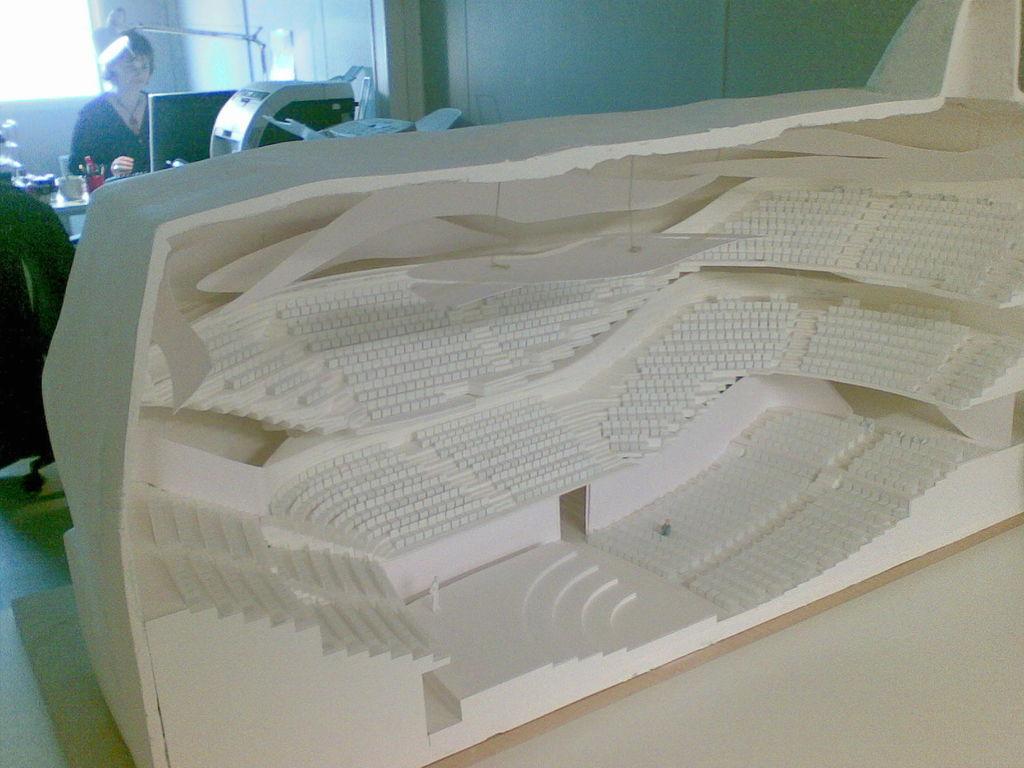How would you summarize this image in a sentence or two? In the center of the image, we can see a decor and in the background, there is a lady and we can see a monitor and some machines, rods and we can see some other objects and there is a wall. At the bottom, there is floor. 